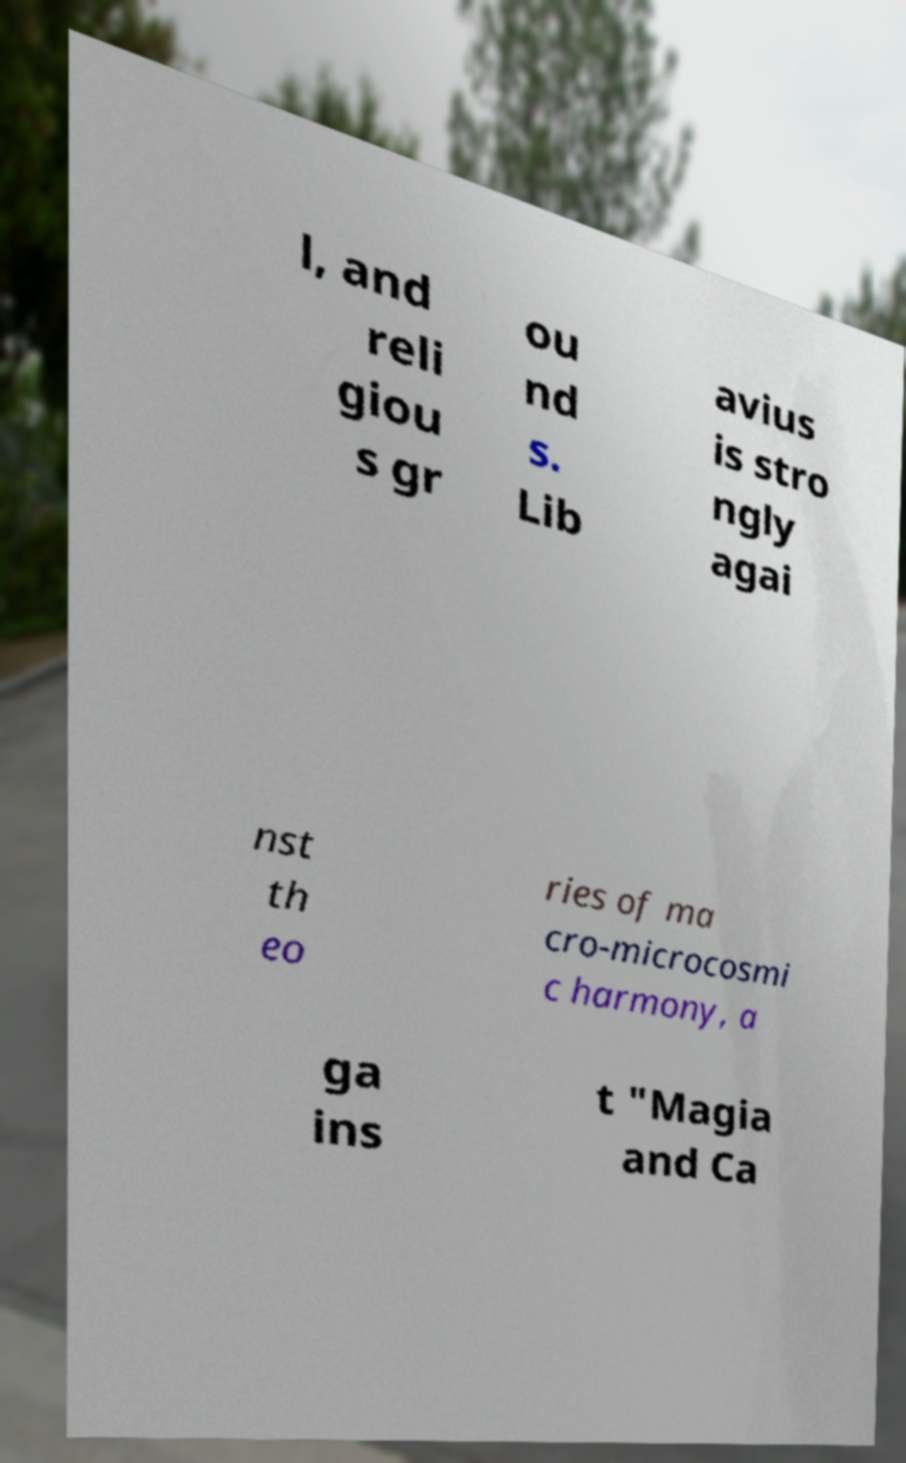Could you extract and type out the text from this image? l, and reli giou s gr ou nd s. Lib avius is stro ngly agai nst th eo ries of ma cro-microcosmi c harmony, a ga ins t "Magia and Ca 